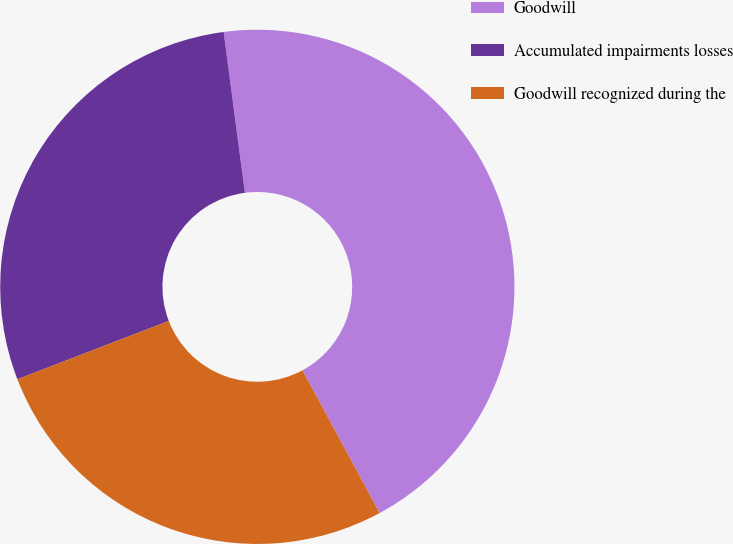Convert chart to OTSL. <chart><loc_0><loc_0><loc_500><loc_500><pie_chart><fcel>Goodwill<fcel>Accumulated impairments losses<fcel>Goodwill recognized during the<nl><fcel>44.2%<fcel>28.76%<fcel>27.04%<nl></chart> 